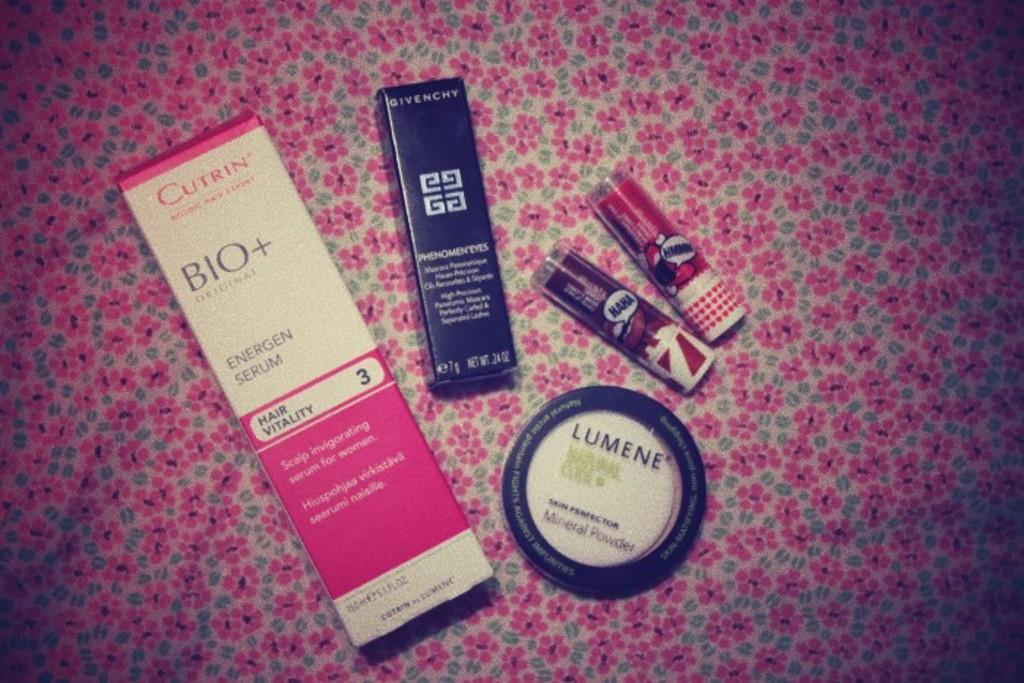<image>
Summarize the visual content of the image. Several beauty products including a mineral powder from Lumene 